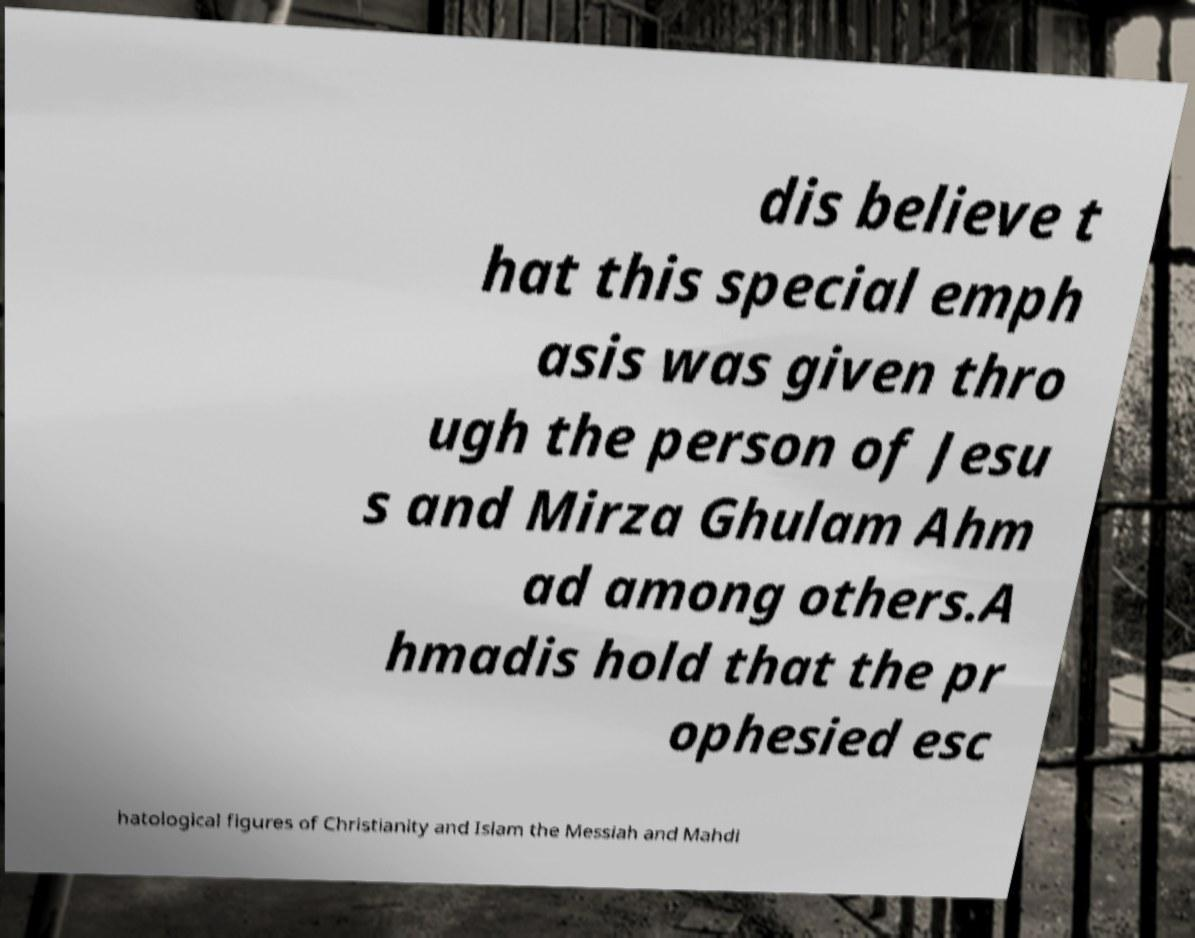For documentation purposes, I need the text within this image transcribed. Could you provide that? dis believe t hat this special emph asis was given thro ugh the person of Jesu s and Mirza Ghulam Ahm ad among others.A hmadis hold that the pr ophesied esc hatological figures of Christianity and Islam the Messiah and Mahdi 